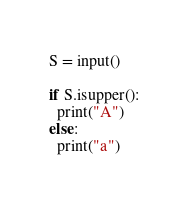Convert code to text. <code><loc_0><loc_0><loc_500><loc_500><_Python_>S = input()

if S.isupper():
  print("A")
else:
  print("a")</code> 